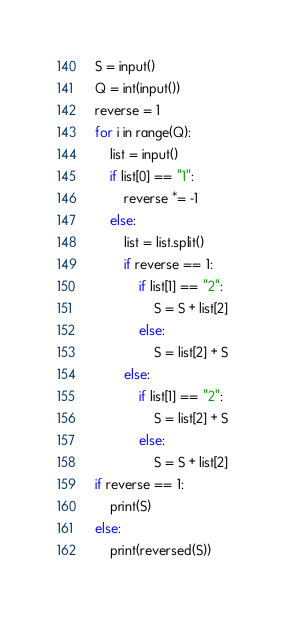Convert code to text. <code><loc_0><loc_0><loc_500><loc_500><_Python_>S = input()
Q = int(input())
reverse = 1
for i in range(Q):
    list = input()
    if list[0] == "1":
        reverse *= -1
    else:
        list = list.split()
        if reverse == 1:
            if list[1] == "2":
                S = S + list[2]
            else:
                S = list[2] + S
        else:
            if list[1] == "2":
                S = list[2] + S
            else:
                S = S + list[2]
if reverse == 1:
    print(S)
else:
    print(reversed(S))
</code> 